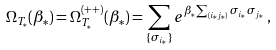<formula> <loc_0><loc_0><loc_500><loc_500>\Omega _ { T _ { * } } ( \beta _ { * } ) = \Omega _ { T _ { * } } ^ { ( + + ) } ( \beta _ { * } ) = \sum _ { \{ \sigma _ { i _ { * } } \} } e ^ { \beta _ { * } \sum _ { ( i _ { * } j _ { * } ) } \sigma _ { i _ { * } } \sigma _ { j _ { * } } } \, ,</formula> 